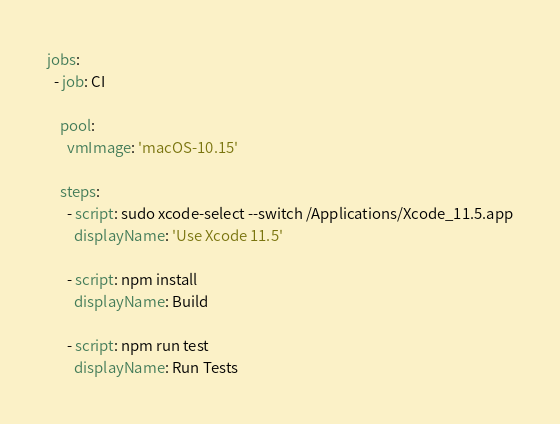<code> <loc_0><loc_0><loc_500><loc_500><_YAML_>jobs:
  - job: CI

    pool:
      vmImage: 'macOS-10.15'

    steps:
      - script: sudo xcode-select --switch /Applications/Xcode_11.5.app
        displayName: 'Use Xcode 11.5'

      - script: npm install
        displayName: Build

      - script: npm run test
        displayName: Run Tests
</code> 